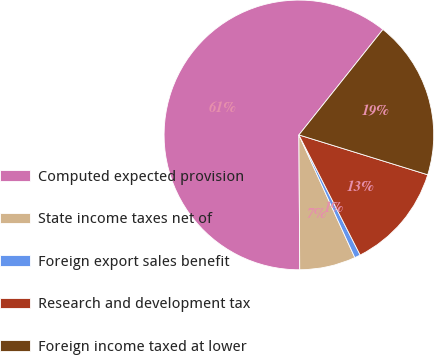Convert chart. <chart><loc_0><loc_0><loc_500><loc_500><pie_chart><fcel>Computed expected provision<fcel>State income taxes net of<fcel>Foreign export sales benefit<fcel>Research and development tax<fcel>Foreign income taxed at lower<nl><fcel>60.81%<fcel>6.71%<fcel>0.7%<fcel>12.72%<fcel>19.07%<nl></chart> 